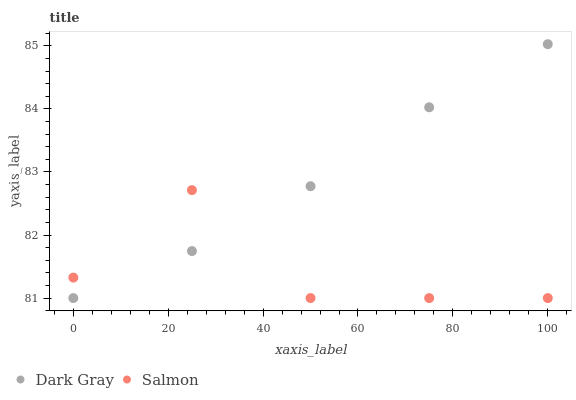Does Salmon have the minimum area under the curve?
Answer yes or no. Yes. Does Dark Gray have the maximum area under the curve?
Answer yes or no. Yes. Does Salmon have the maximum area under the curve?
Answer yes or no. No. Is Dark Gray the smoothest?
Answer yes or no. Yes. Is Salmon the roughest?
Answer yes or no. Yes. Is Salmon the smoothest?
Answer yes or no. No. Does Dark Gray have the lowest value?
Answer yes or no. Yes. Does Dark Gray have the highest value?
Answer yes or no. Yes. Does Salmon have the highest value?
Answer yes or no. No. Does Dark Gray intersect Salmon?
Answer yes or no. Yes. Is Dark Gray less than Salmon?
Answer yes or no. No. Is Dark Gray greater than Salmon?
Answer yes or no. No. 